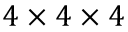<formula> <loc_0><loc_0><loc_500><loc_500>4 \times 4 \times 4</formula> 